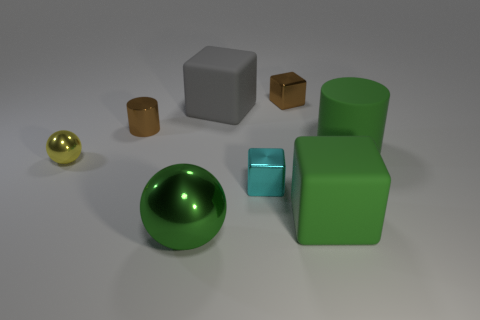Does the gray block have the same size as the brown shiny object that is on the left side of the brown metallic cube?
Your answer should be compact. No. What number of small blocks are left of the tiny block that is behind the cylinder that is left of the cyan metal cube?
Provide a succinct answer. 1. How many small things are behind the metal cylinder?
Ensure brevity in your answer.  1. The rubber thing that is left of the small brown metal thing that is on the right side of the tiny cyan metallic object is what color?
Offer a terse response. Gray. What number of other objects are there of the same material as the tiny brown block?
Keep it short and to the point. 4. Are there an equal number of green blocks that are to the left of the small brown metal block and large green matte objects?
Your answer should be compact. No. There is a cylinder that is to the right of the shiny object that is behind the cube that is left of the small cyan metallic thing; what is it made of?
Your answer should be compact. Rubber. There is a large thing that is behind the matte cylinder; what color is it?
Ensure brevity in your answer.  Gray. Is there any other thing that has the same shape as the large gray thing?
Provide a succinct answer. Yes. There is a cylinder that is to the right of the tiny brown metal object that is to the left of the cyan shiny thing; how big is it?
Make the answer very short. Large. 